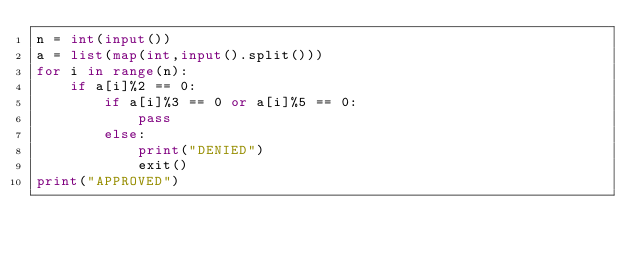<code> <loc_0><loc_0><loc_500><loc_500><_Python_>n = int(input())
a = list(map(int,input().split()))
for i in range(n):
    if a[i]%2 == 0:
        if a[i]%3 == 0 or a[i]%5 == 0:
            pass
        else:
            print("DENIED")
            exit()
print("APPROVED")</code> 